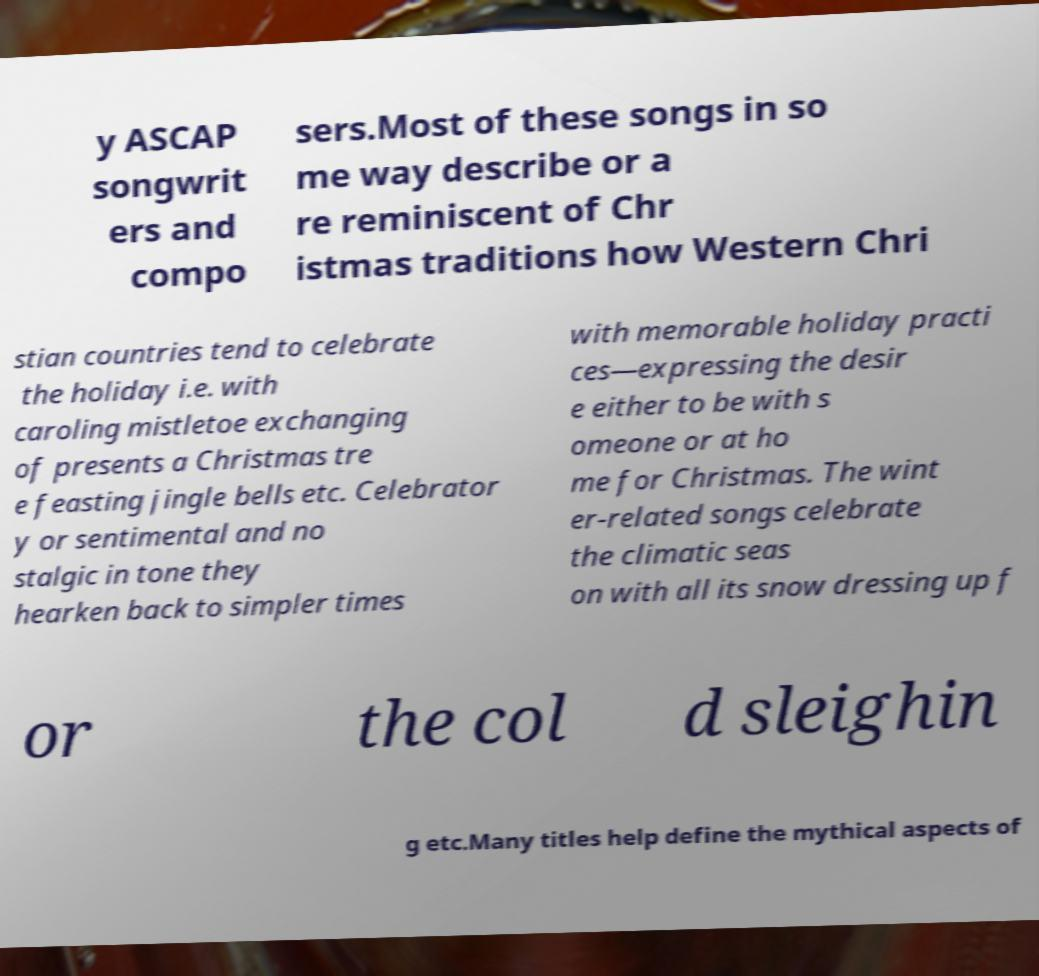Could you assist in decoding the text presented in this image and type it out clearly? y ASCAP songwrit ers and compo sers.Most of these songs in so me way describe or a re reminiscent of Chr istmas traditions how Western Chri stian countries tend to celebrate the holiday i.e. with caroling mistletoe exchanging of presents a Christmas tre e feasting jingle bells etc. Celebrator y or sentimental and no stalgic in tone they hearken back to simpler times with memorable holiday practi ces—expressing the desir e either to be with s omeone or at ho me for Christmas. The wint er-related songs celebrate the climatic seas on with all its snow dressing up f or the col d sleighin g etc.Many titles help define the mythical aspects of 